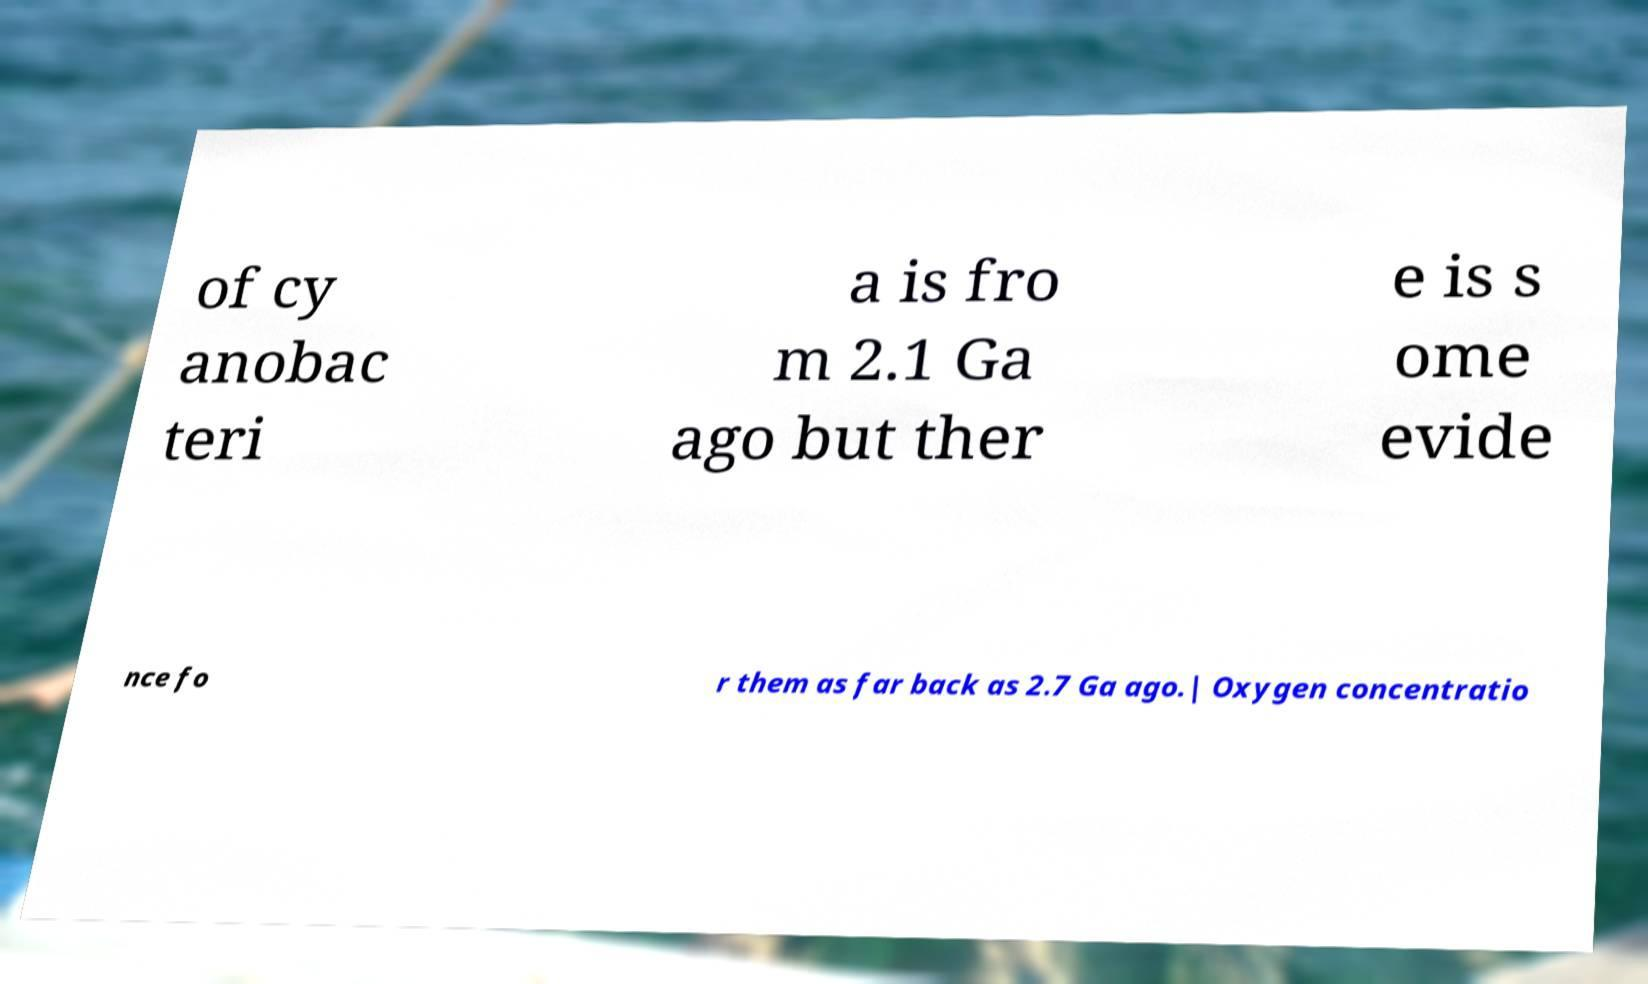Can you read and provide the text displayed in the image?This photo seems to have some interesting text. Can you extract and type it out for me? of cy anobac teri a is fro m 2.1 Ga ago but ther e is s ome evide nce fo r them as far back as 2.7 Ga ago.| Oxygen concentratio 